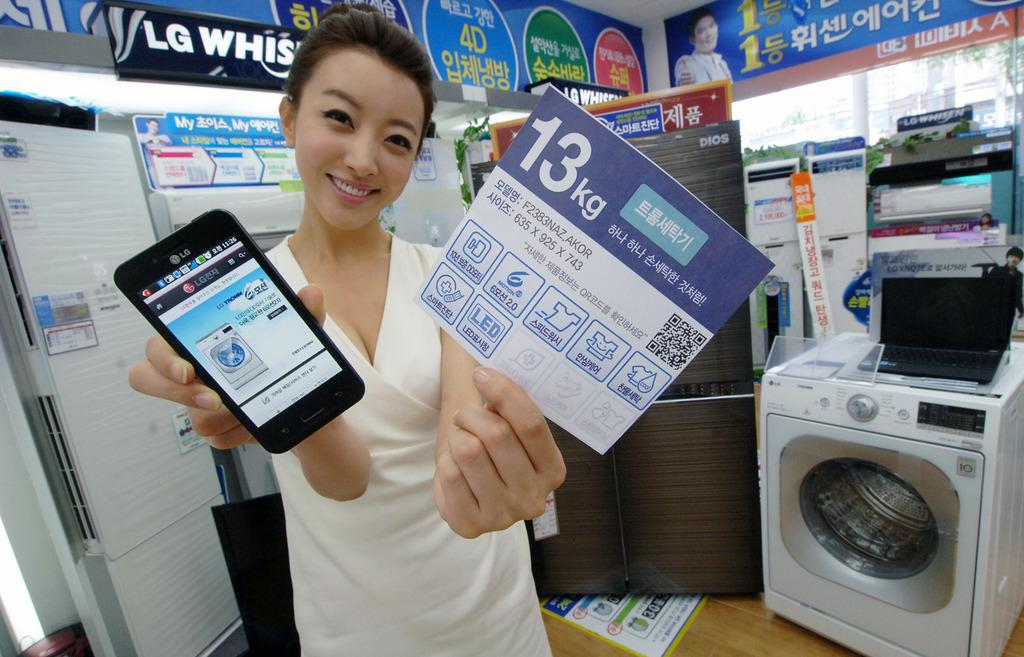<image>
Relay a brief, clear account of the picture shown. LG phone showing a LG washer machine on screen. 